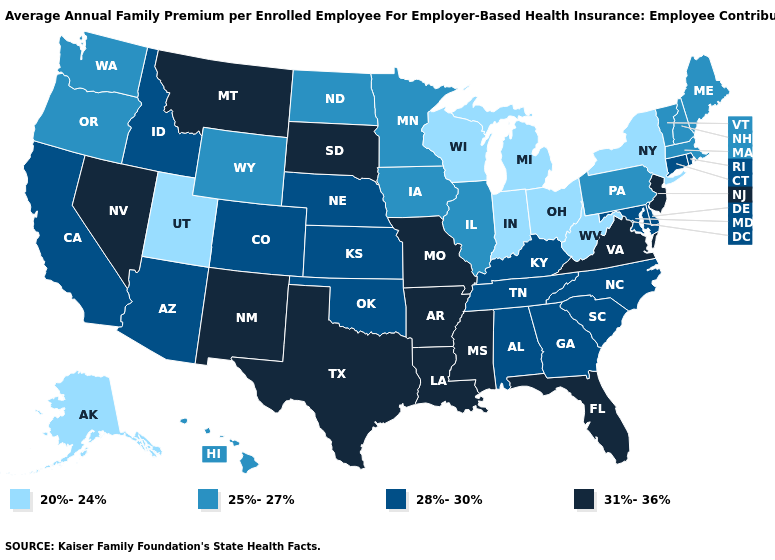What is the lowest value in the MidWest?
Answer briefly. 20%-24%. What is the value of Arizona?
Answer briefly. 28%-30%. Does the map have missing data?
Write a very short answer. No. What is the value of Maryland?
Give a very brief answer. 28%-30%. What is the value of Connecticut?
Write a very short answer. 28%-30%. Which states have the lowest value in the USA?
Concise answer only. Alaska, Indiana, Michigan, New York, Ohio, Utah, West Virginia, Wisconsin. What is the highest value in the Northeast ?
Short answer required. 31%-36%. Does Nevada have a higher value than Kentucky?
Write a very short answer. Yes. What is the value of New York?
Give a very brief answer. 20%-24%. Does California have a higher value than Mississippi?
Be succinct. No. Does Ohio have the lowest value in the USA?
Concise answer only. Yes. What is the highest value in the USA?
Write a very short answer. 31%-36%. Does the map have missing data?
Write a very short answer. No. Does Mississippi have the highest value in the USA?
Concise answer only. Yes. What is the value of Montana?
Answer briefly. 31%-36%. 